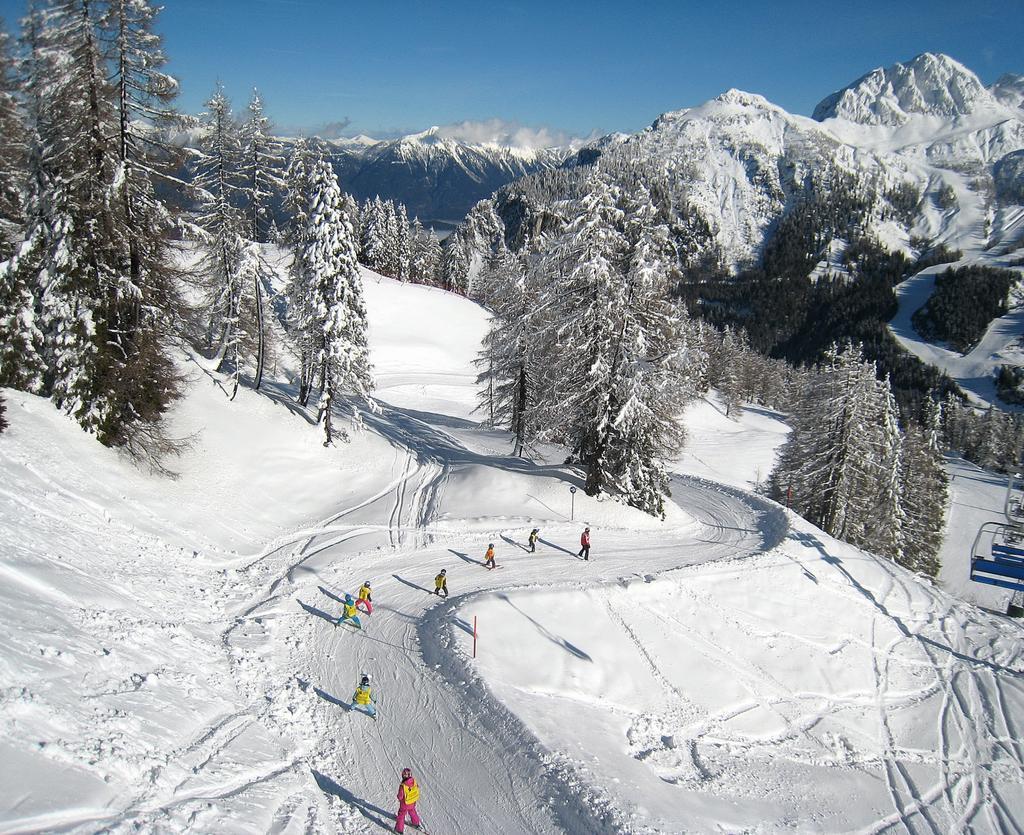Please provide a concise description of this image. In this picture there are mountains. In the middle of the image there are group of people skiing. On the right side of the image there are cable cars. At the back there are trees and there is snow on the trees. At the top there is sky. At the bottom there is snow. 